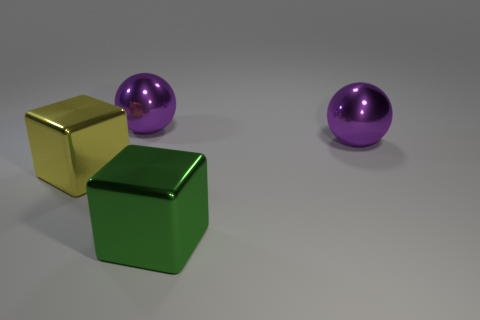Are there any large blue metallic balls?
Your answer should be compact. No. There is another metallic thing that is the same shape as the yellow object; what color is it?
Make the answer very short. Green. The shiny block that is the same size as the green metallic thing is what color?
Provide a succinct answer. Yellow. Is the material of the yellow block the same as the green cube?
Your response must be concise. Yes. What material is the block that is behind the big green cube?
Provide a succinct answer. Metal. What number of small objects are purple rubber balls or purple metallic balls?
Keep it short and to the point. 0. Is there another block made of the same material as the green cube?
Give a very brief answer. Yes. There is a metal cube that is to the right of the yellow metal block; is its size the same as the yellow metallic cube?
Give a very brief answer. Yes. Are there any blocks in front of the yellow object left of the big shiny object in front of the yellow metal cube?
Offer a very short reply. Yes. What number of metallic objects are either big balls or large gray cylinders?
Make the answer very short. 2. 